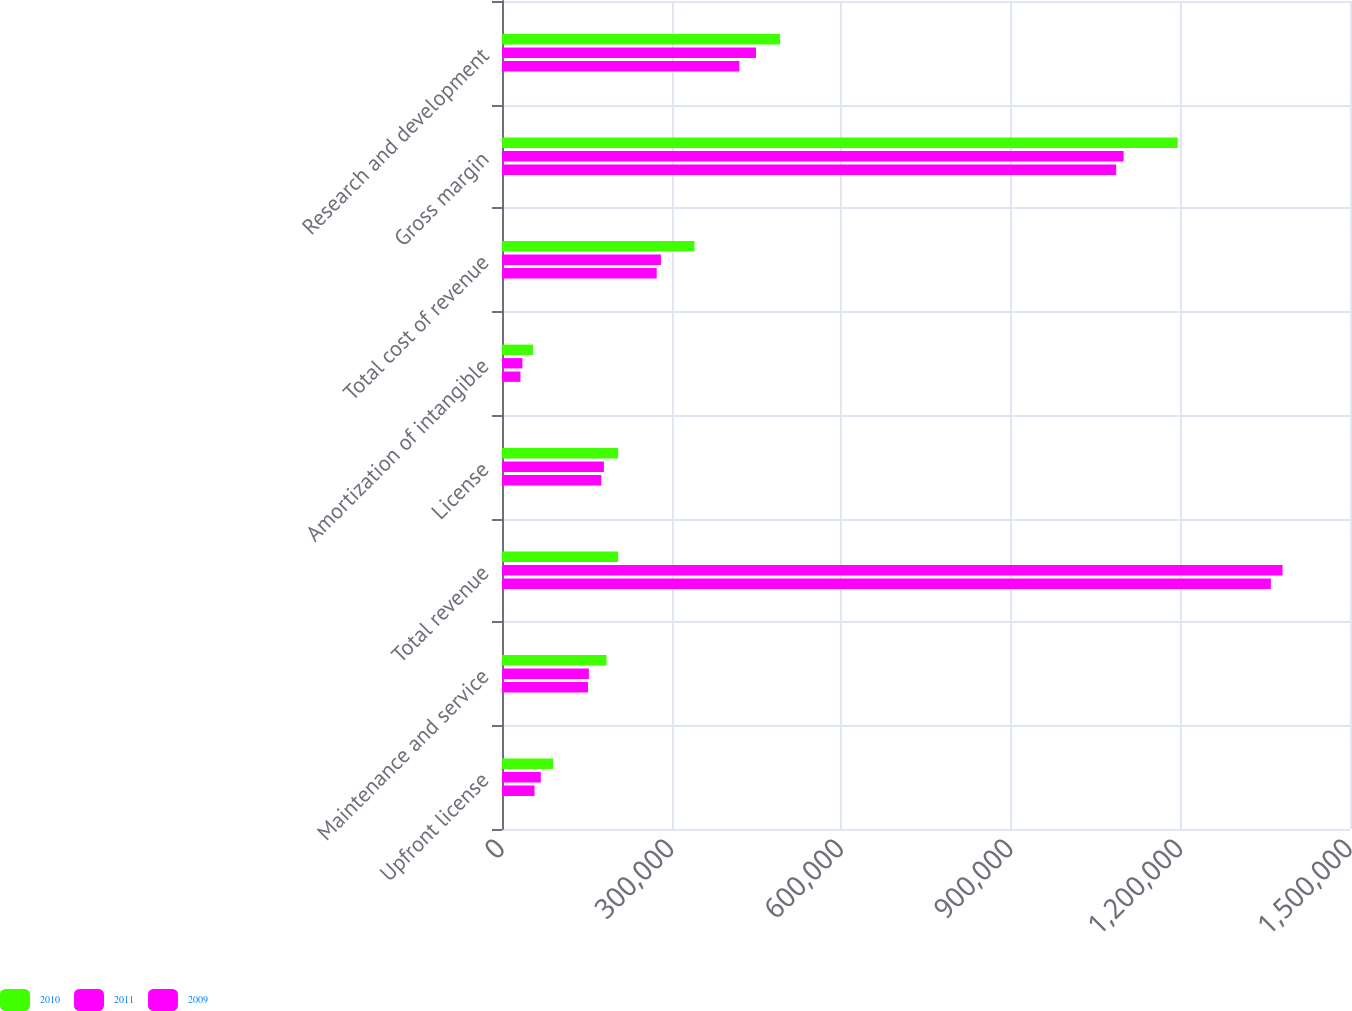Convert chart to OTSL. <chart><loc_0><loc_0><loc_500><loc_500><stacked_bar_chart><ecel><fcel>Upfront license<fcel>Maintenance and service<fcel>Total revenue<fcel>License<fcel>Amortization of intangible<fcel>Total cost of revenue<fcel>Gross margin<fcel>Research and development<nl><fcel>2010<fcel>90531<fcel>184770<fcel>205390<fcel>205390<fcel>54819<fcel>340450<fcel>1.19519e+06<fcel>491871<nl><fcel>2011<fcel>68618<fcel>153625<fcel>1.38066e+06<fcel>180245<fcel>36103<fcel>281094<fcel>1.09957e+06<fcel>449229<nl><fcel>2009<fcel>57551<fcel>152021<fcel>1.36004e+06<fcel>175620<fcel>32662<fcel>273650<fcel>1.0864e+06<fcel>419908<nl></chart> 